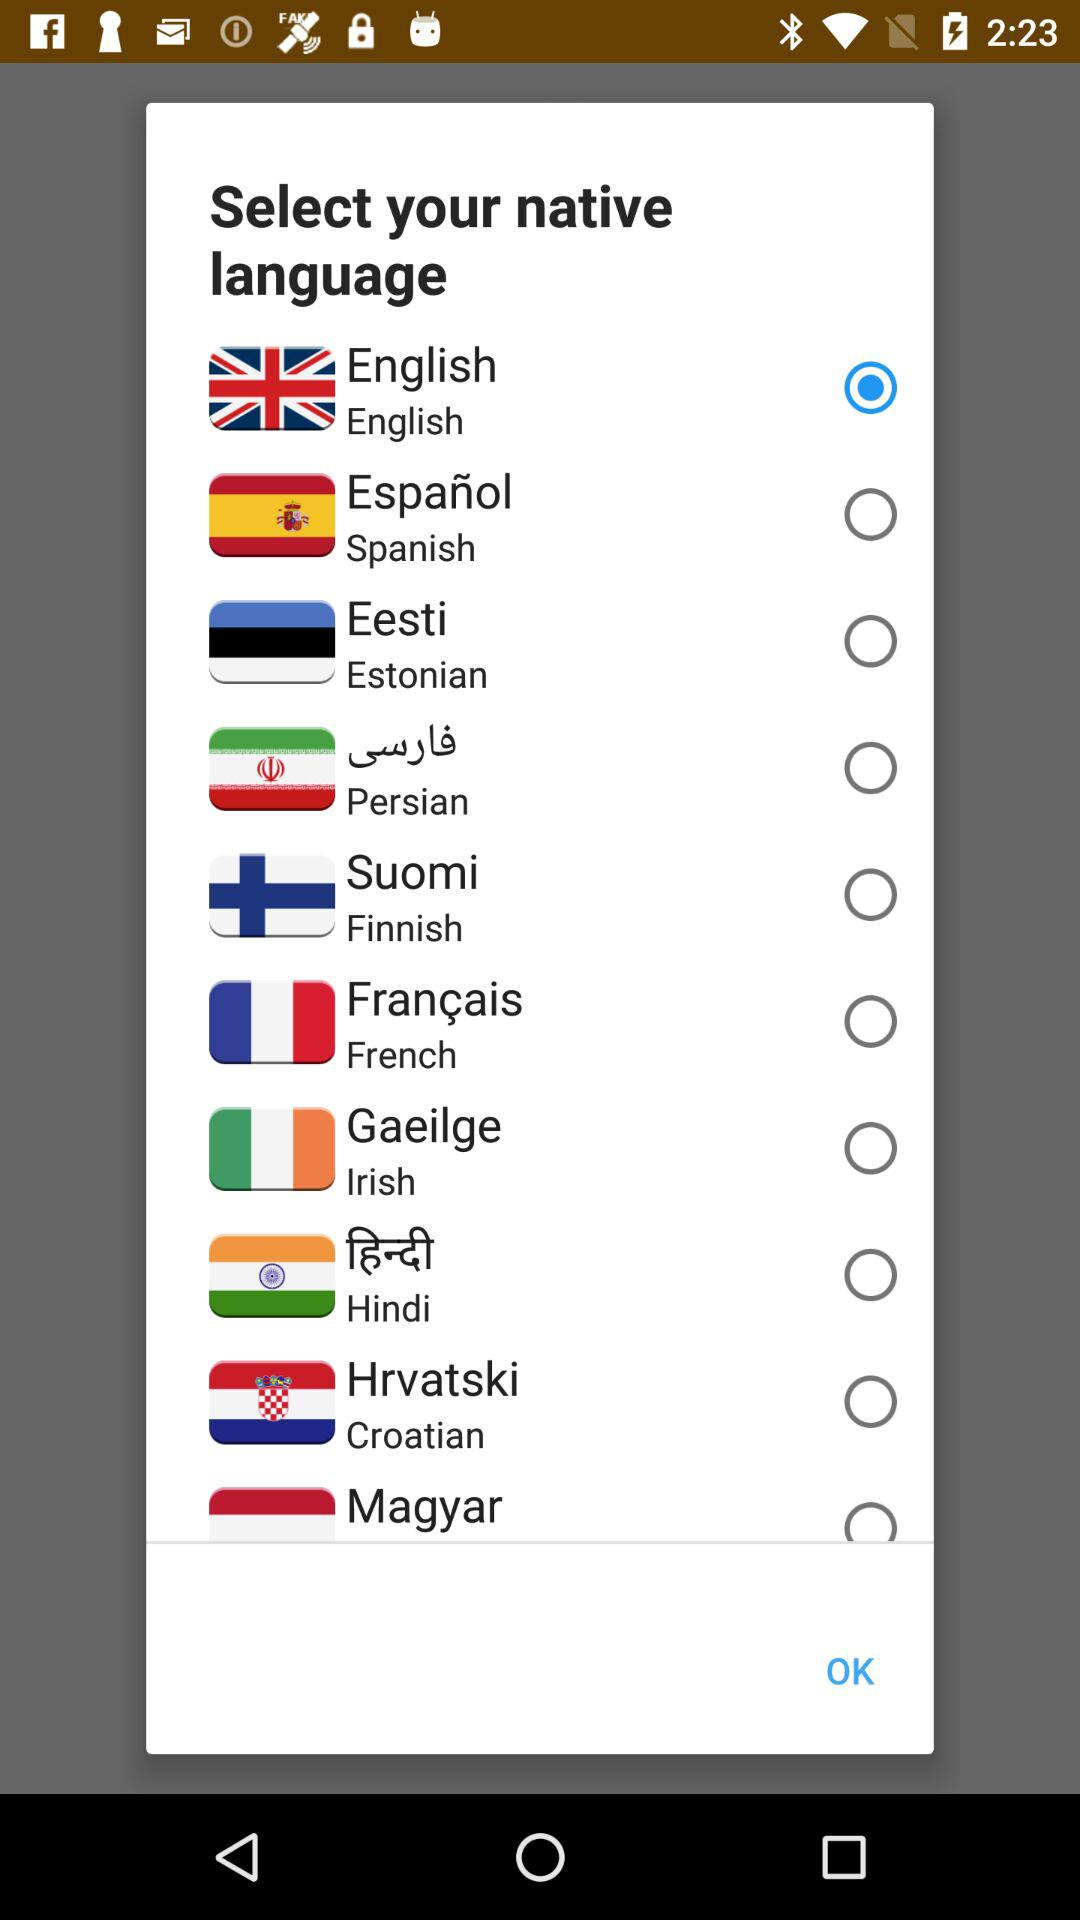How many languages are available to select from?
Answer the question using a single word or phrase. 10 